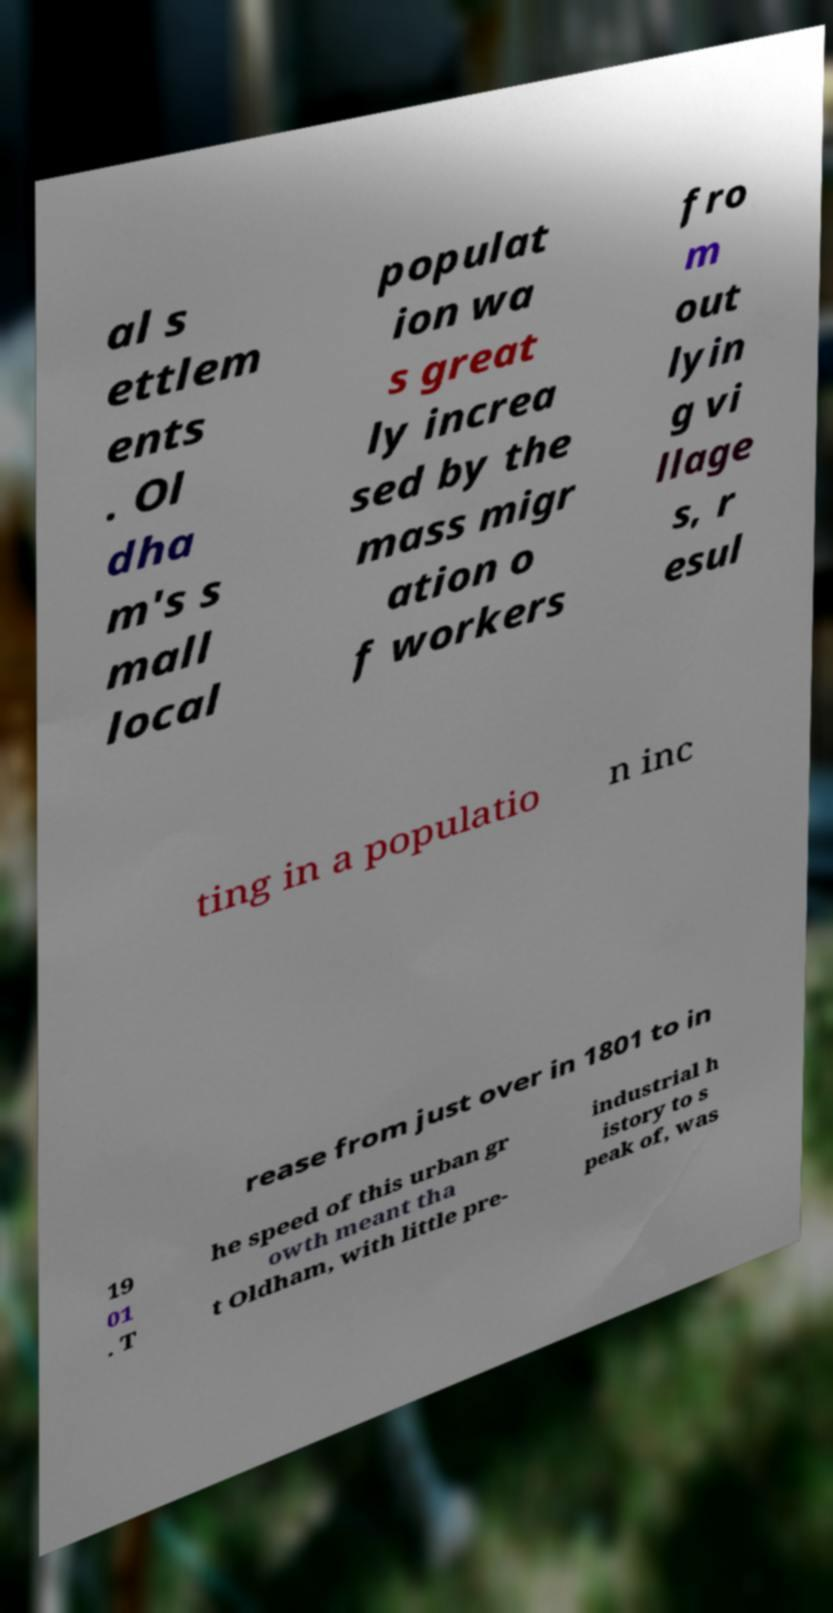Please read and relay the text visible in this image. What does it say? al s ettlem ents . Ol dha m's s mall local populat ion wa s great ly increa sed by the mass migr ation o f workers fro m out lyin g vi llage s, r esul ting in a populatio n inc rease from just over in 1801 to in 19 01 . T he speed of this urban gr owth meant tha t Oldham, with little pre- industrial h istory to s peak of, was 